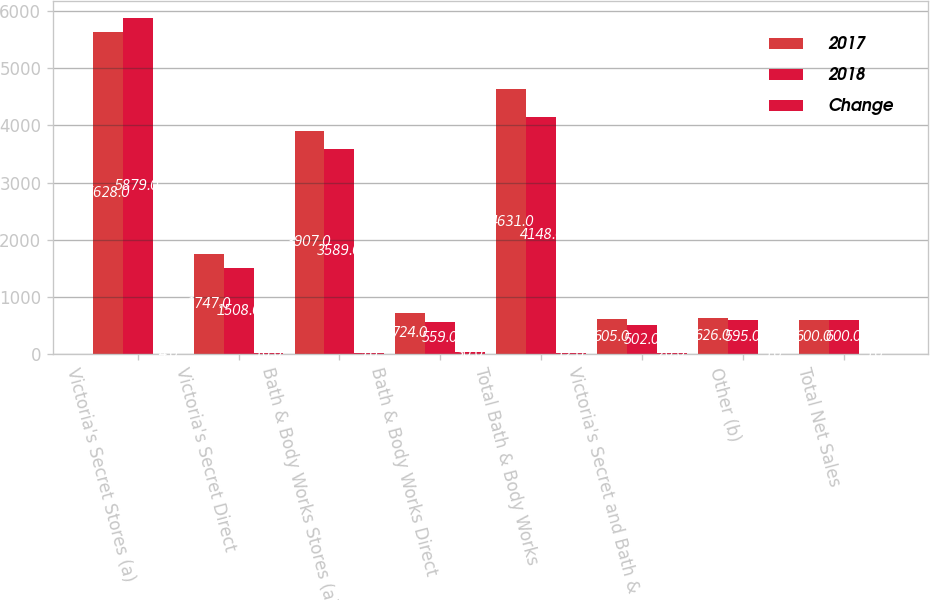Convert chart to OTSL. <chart><loc_0><loc_0><loc_500><loc_500><stacked_bar_chart><ecel><fcel>Victoria's Secret Stores (a)<fcel>Victoria's Secret Direct<fcel>Bath & Body Works Stores (a)<fcel>Bath & Body Works Direct<fcel>Total Bath & Body Works<fcel>Victoria's Secret and Bath &<fcel>Other (b)<fcel>Total Net Sales<nl><fcel>2017<fcel>5628<fcel>1747<fcel>3907<fcel>724<fcel>4631<fcel>605<fcel>626<fcel>600<nl><fcel>2018<fcel>5879<fcel>1508<fcel>3589<fcel>559<fcel>4148<fcel>502<fcel>595<fcel>600<nl><fcel>Change<fcel>4<fcel>16<fcel>9<fcel>30<fcel>12<fcel>20<fcel>5<fcel>5<nl></chart> 